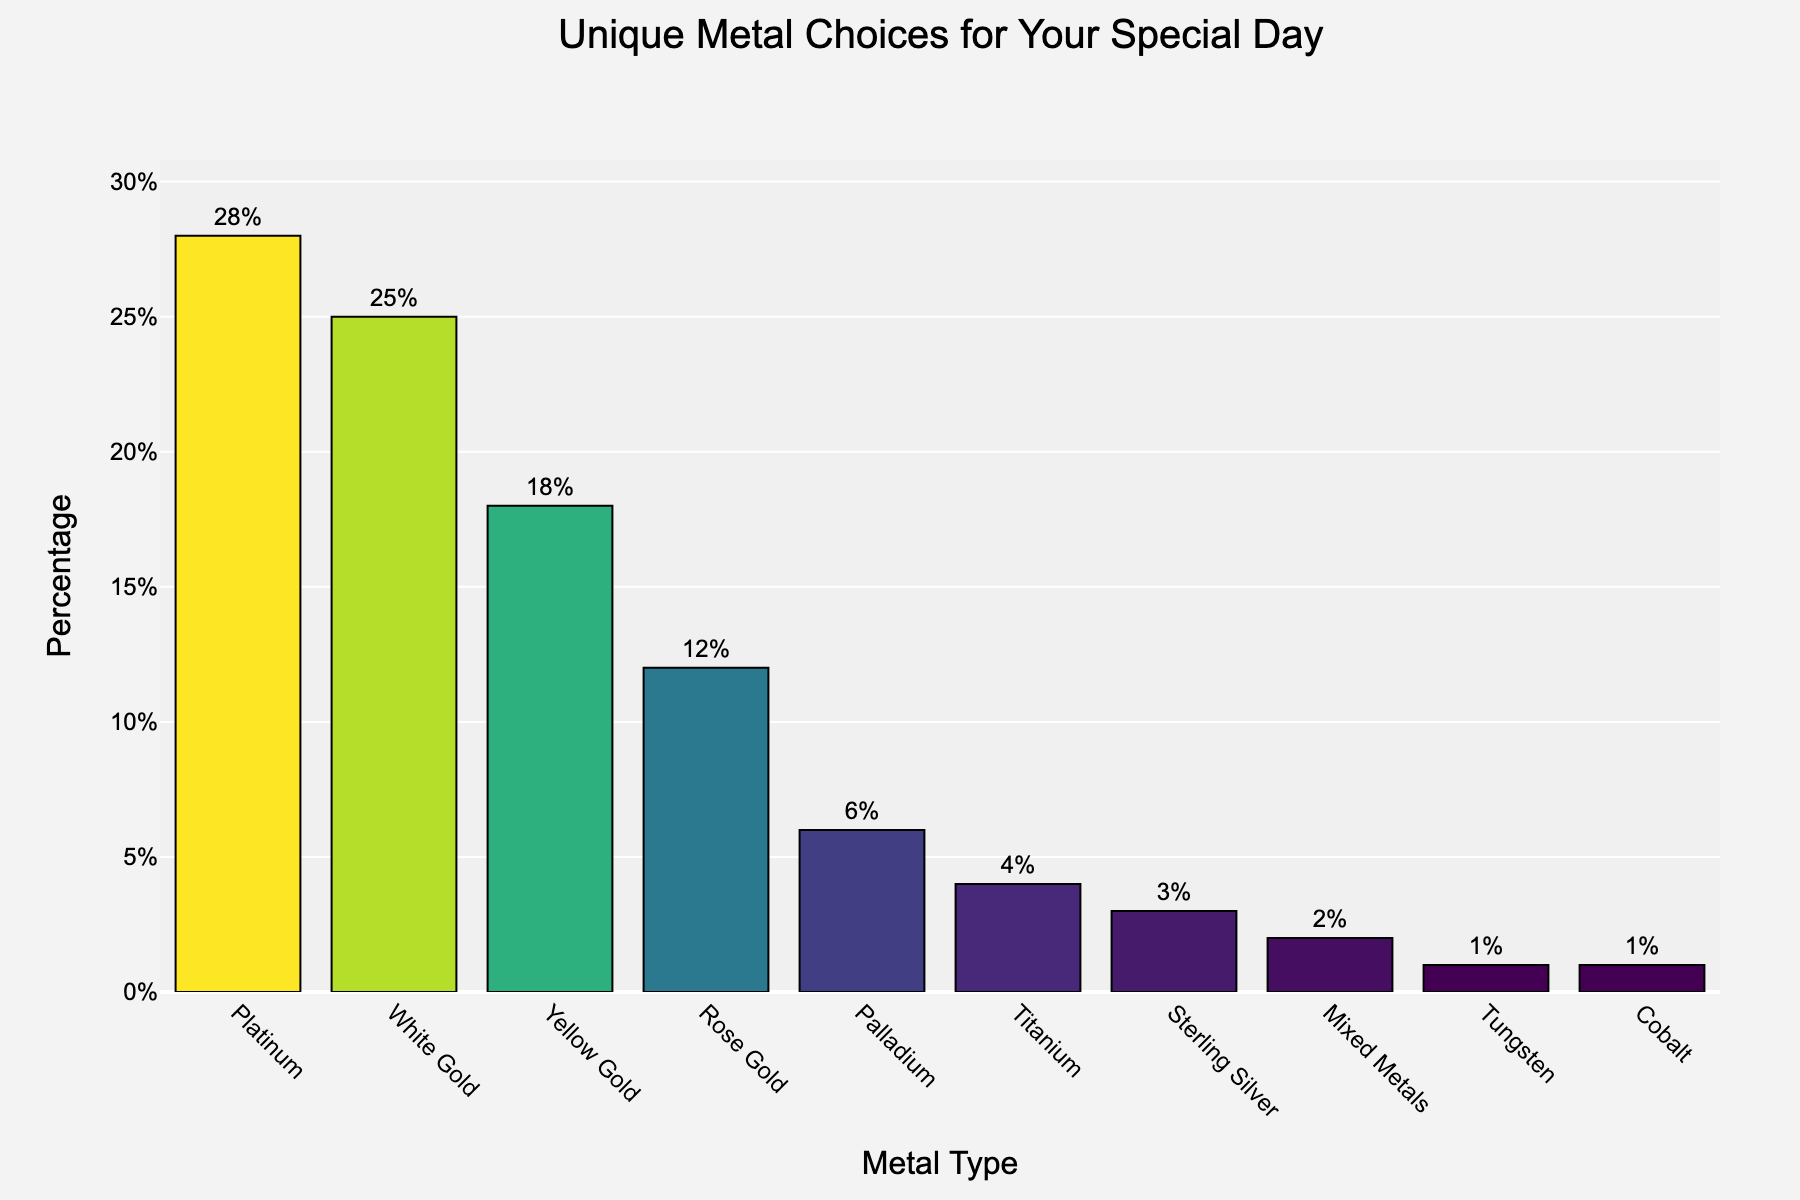What is the most preferred metal type for wedding bands among modern couples? Looking at the chart, the tallest bar represents Platinum with the highest percentage.
Answer: Platinum Which metal types have the same level of preference among modern couples according to the chart? The bars for Tungsten and Cobalt are of equal height, both at 1%.
Answer: Tungsten and Cobalt How much more popular is White Gold compared to Rose Gold? Subtract the percentage of Rose Gold (12%) from the percentage of White Gold (25%). 25% - 12% = 13%
Answer: 13% What is the combined percentage of couples that prefer Yellow Gold and Rose Gold? Add the percentages for Yellow Gold (18%) and Rose Gold (12%). 18% + 12% = 30%
Answer: 30% Which metal type is preferred by fewer couples than Titanium but more than Sterling Silver? The bar height indicates Palladium (6%), which falls between Titanium (4%) and Sterling Silver (3%).
Answer: Palladium How many metal types have a preference percentage greater than 20%? Identify the bars representing percentages greater than 20%, which are Platinum (28%) and White Gold (25%). There are 2 such bars.
Answer: 2 What is the percentage difference between the most and least popular metal types? Subtract the percentage of the least popular metal (1% for Tungsten or Cobalt) from the most popular metal (28% for Platinum). 28% - 1% = 27%
Answer: 27% Considering only the top three preferred metal types, what is their total combined percentage? Add the percentages for Platinum (28%), White Gold (25%), and Yellow Gold (18%). 28% + 25% + 18% = 71%
Answer: 71% Which metal type has a visual mark color closer to green on the "Viridis" colorscale used in the chart? The bar for Yellow Gold visually appears closer to green on the "Viridis" colorscale.
Answer: Yellow Gold If 1,000 couples were surveyed, approximately how many of them would prefer Palladium for their wedding bands? Multiply the percentage of Palladium preference (6%) by the number of couples surveyed (1,000). 0.06 * 1000 = 60
Answer: 60 